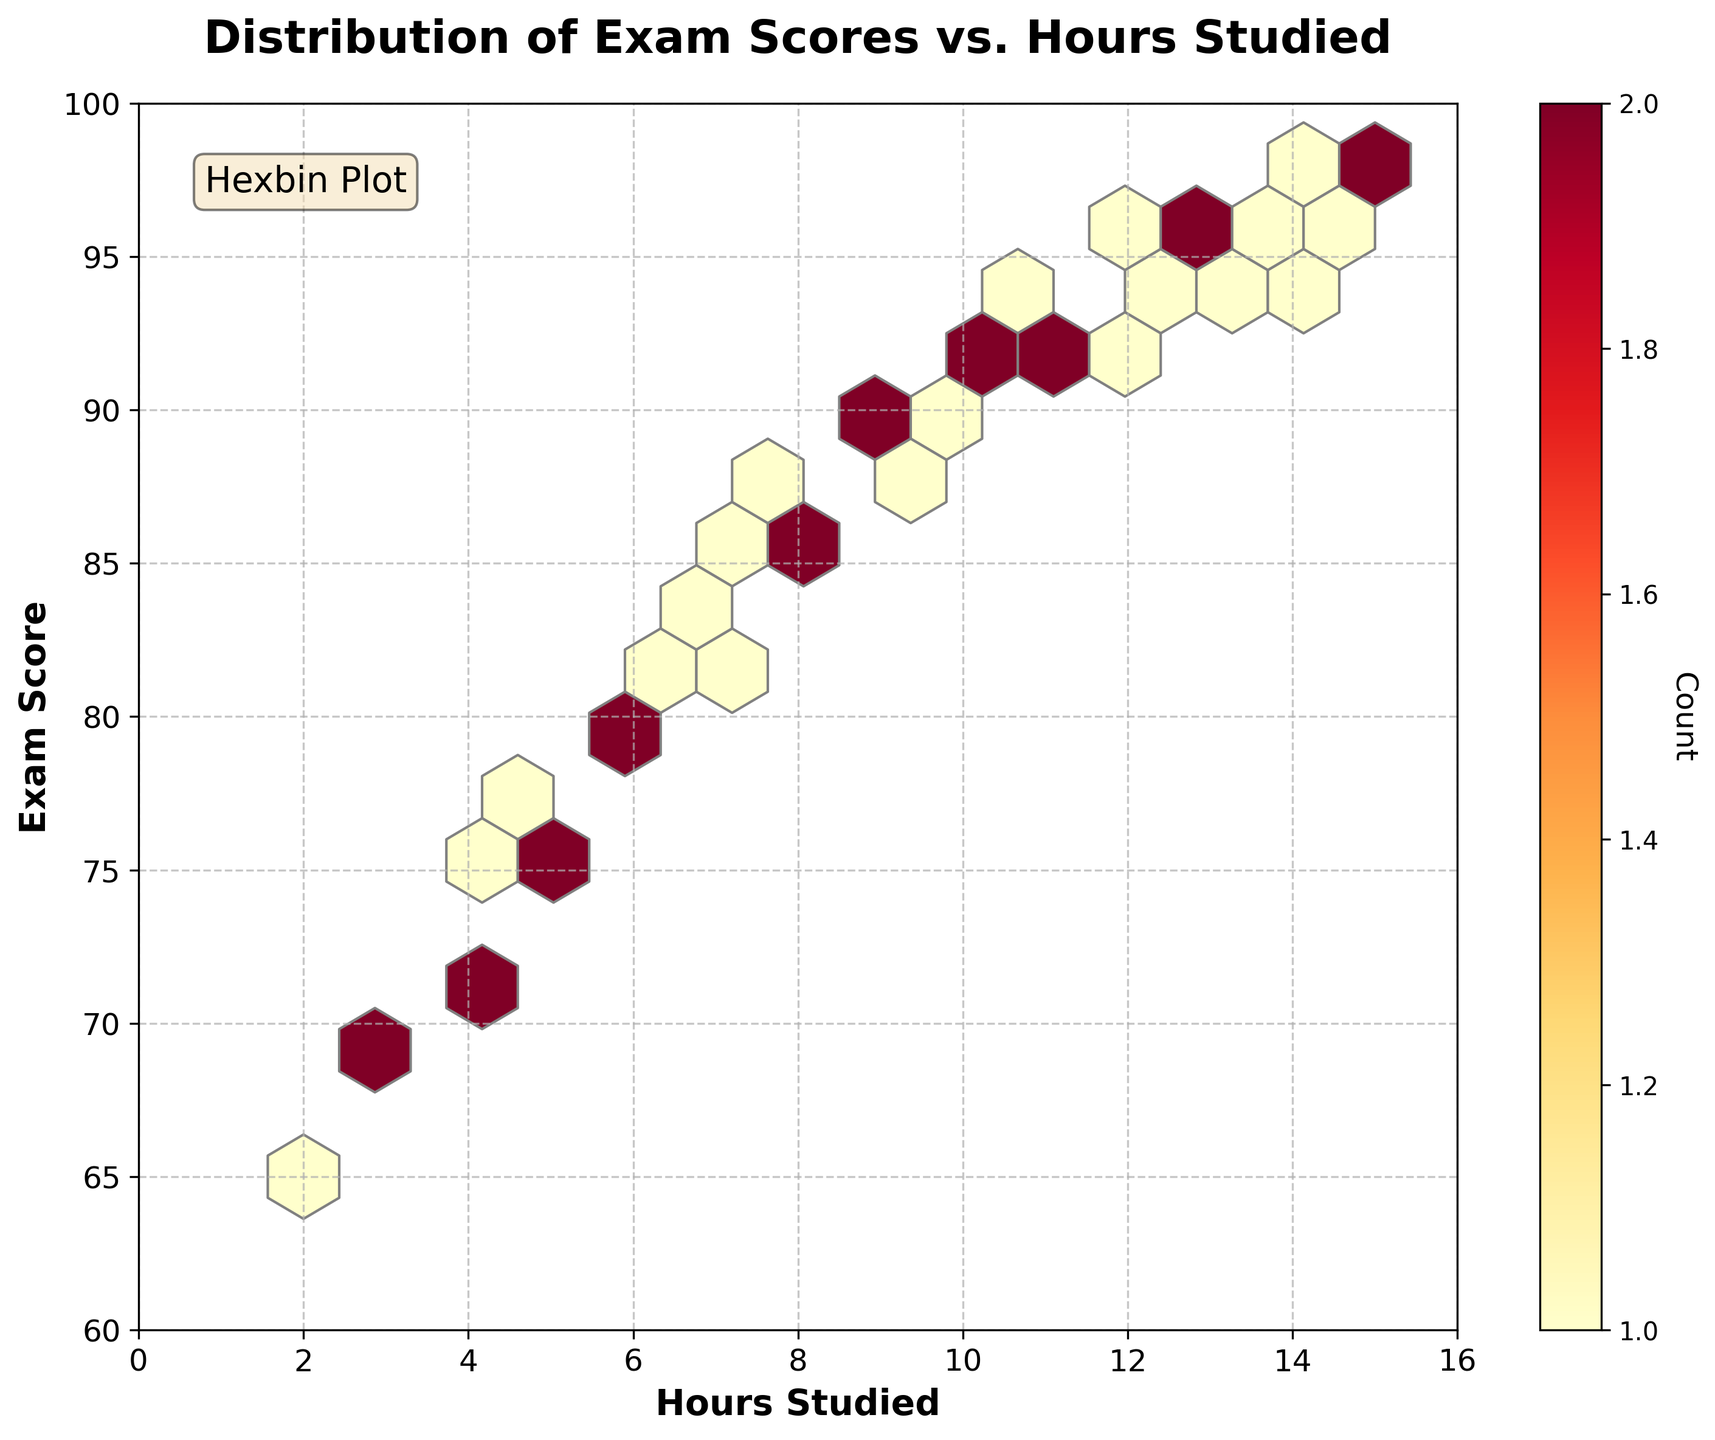What is the title of the plot? The title of the plot is displayed at the top and reads "Distribution of Exam Scores vs. Hours Studied."
Answer: Distribution of Exam Scores vs. Hours Studied What are the labels for the X and Y axes? The X-axis label is "Hours Studied," and the Y-axis label is "Exam Score." These labels are found next to their respective axes.
Answer: Hours Studied, Exam Score What is the color of the highest density areas in the hexbin plot? The highest density areas in the plot are represented by the darkest shade in the 'YlOrRd' colormap, which appears as dark red.
Answer: Dark red What is the range for the X-axis and Y-axis? The X-axis ranges from 0 to 16 hours, and the Y-axis ranges from 60 to 100 exam scores. These ranges are clearly indicated by the axis tick marks.
Answer: 0 to 16 (X-axis), 60 to 100 (Y-axis) What's the relationship between hours studied and exam scores based on the plot? The hexbin plot shows that as the hours studied increase, the exam scores also tend to increase. This can be inferred from the clustering of data points moving upward and to the right.
Answer: Positive correlation Which range of hours studied has the highest concentration of exam scores? The highest concentration is observed in the range of 10 to 12 hours studied. This can be seen from the darkest hexagons in the plot which represent the highest density of data points.
Answer: 10 to 12 hours How many data points are represented by the hexagon with the highest count? To determine this, refer to the color bar on the side which indicates the count for the color intensity. The darkest color corresponding to the highest count appears to represent around 3 to 4 data points.
Answer: 3 to 4 Which hours studied have the lowest recorded exam scores and what are those scores? The lowest recorded exam scores appear around 65, which can be seen for the data points at around 2 to 3 hours studied.
Answer: Around 2 to 3 hours, Scores: 65 Do any hours studied result in a score of 100? No hexagon reaches the upper limit of the Y-axis, which is 100 exam score, indicating that no scores of 100 were recorded for any hours studied.
Answer: No How does variability in exam scores change with increasing hours studied? Initially, the variability is high with scores ranging from 65 to 78 for lower hours studied. As hours increase, variability decreases, and scores cluster closer together around higher values (85-97).
Answer: Decreases 